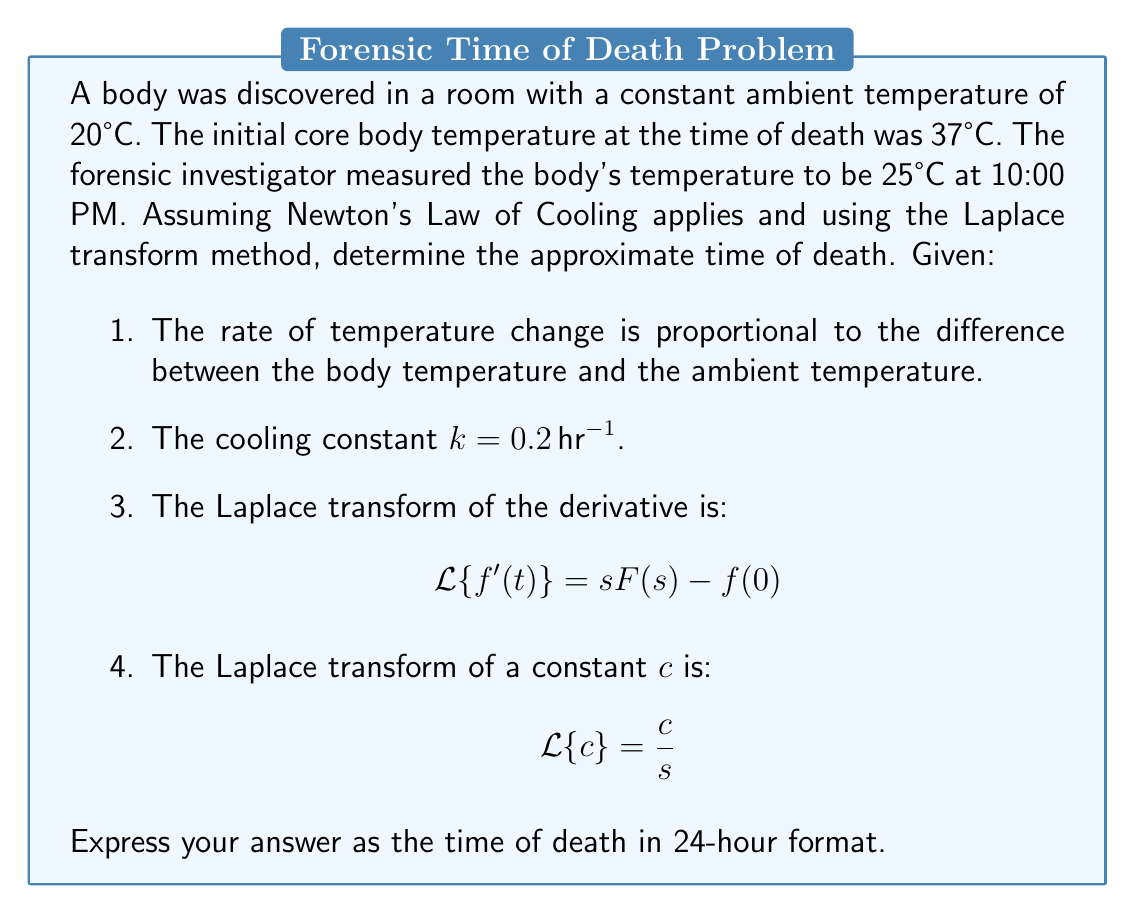Can you solve this math problem? Let's approach this step-by-step using the Laplace transform method:

1) Let T(t) be the temperature of the body at time t. The differential equation describing Newton's Law of Cooling is:

   $$\frac{dT}{dt} = -k(T - T_a)$$

   where T_a is the ambient temperature (20°C) and k = 0.2 hr^(-1).

2) Rewrite the equation:

   $$\frac{dT}{dt} + 0.2T = 0.2 \cdot 20 = 4$$

3) Apply the Laplace transform to both sides:

   $$\mathcal{L}\{\frac{dT}{dt}\} + 0.2\mathcal{L}\{T\} = \mathcal{L}\{4\}$$

4) Using the Laplace transform properties:

   $$sT(s) - T(0) + 0.2T(s) = \frac{4}{s}$$

   where T(0) = 37°C (initial temperature)

5) Solve for T(s):

   $$(s + 0.2)T(s) = 37 + \frac{4}{s}$$
   
   $$T(s) = \frac{37}{s + 0.2} + \frac{4}{s(s + 0.2)}$$

6) Perform partial fraction decomposition:

   $$T(s) = \frac{37}{s + 0.2} + \frac{20}{s} - \frac{20}{s + 0.2}$$

7) Take the inverse Laplace transform:

   $$T(t) = 37e^{-0.2t} + 20 - 20e^{-0.2t} = 20 + 17e^{-0.2t}$$

8) At the time of measurement, T(t) = 25°C. Substitute this into the equation:

   $$25 = 20 + 17e^{-0.2t}$$

9) Solve for t:

   $$5 = 17e^{-0.2t}$$
   $$\ln(\frac{5}{17}) = -0.2t$$
   $$t = \frac{\ln(\frac{17}{5})}{0.2} \approx 6.18 \text{ hours}$$

10) The body was discovered at 10:00 PM, so we subtract 6.18 hours:

    10:00 PM - 6.18 hours ≈ 3:49 PM

Therefore, the estimated time of death is approximately 3:49 PM.
Answer: 15:49 